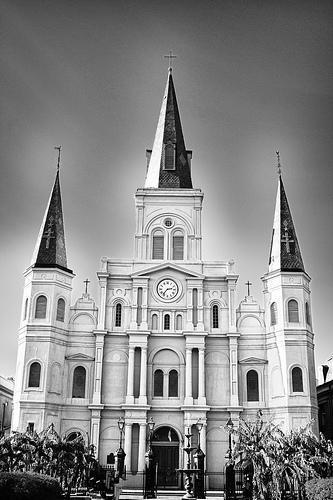How many clocks are visible on this building?
Give a very brief answer. 1. How many crosses are visible on this building?
Give a very brief answer. 2. How many points does this building have?
Give a very brief answer. 3. 